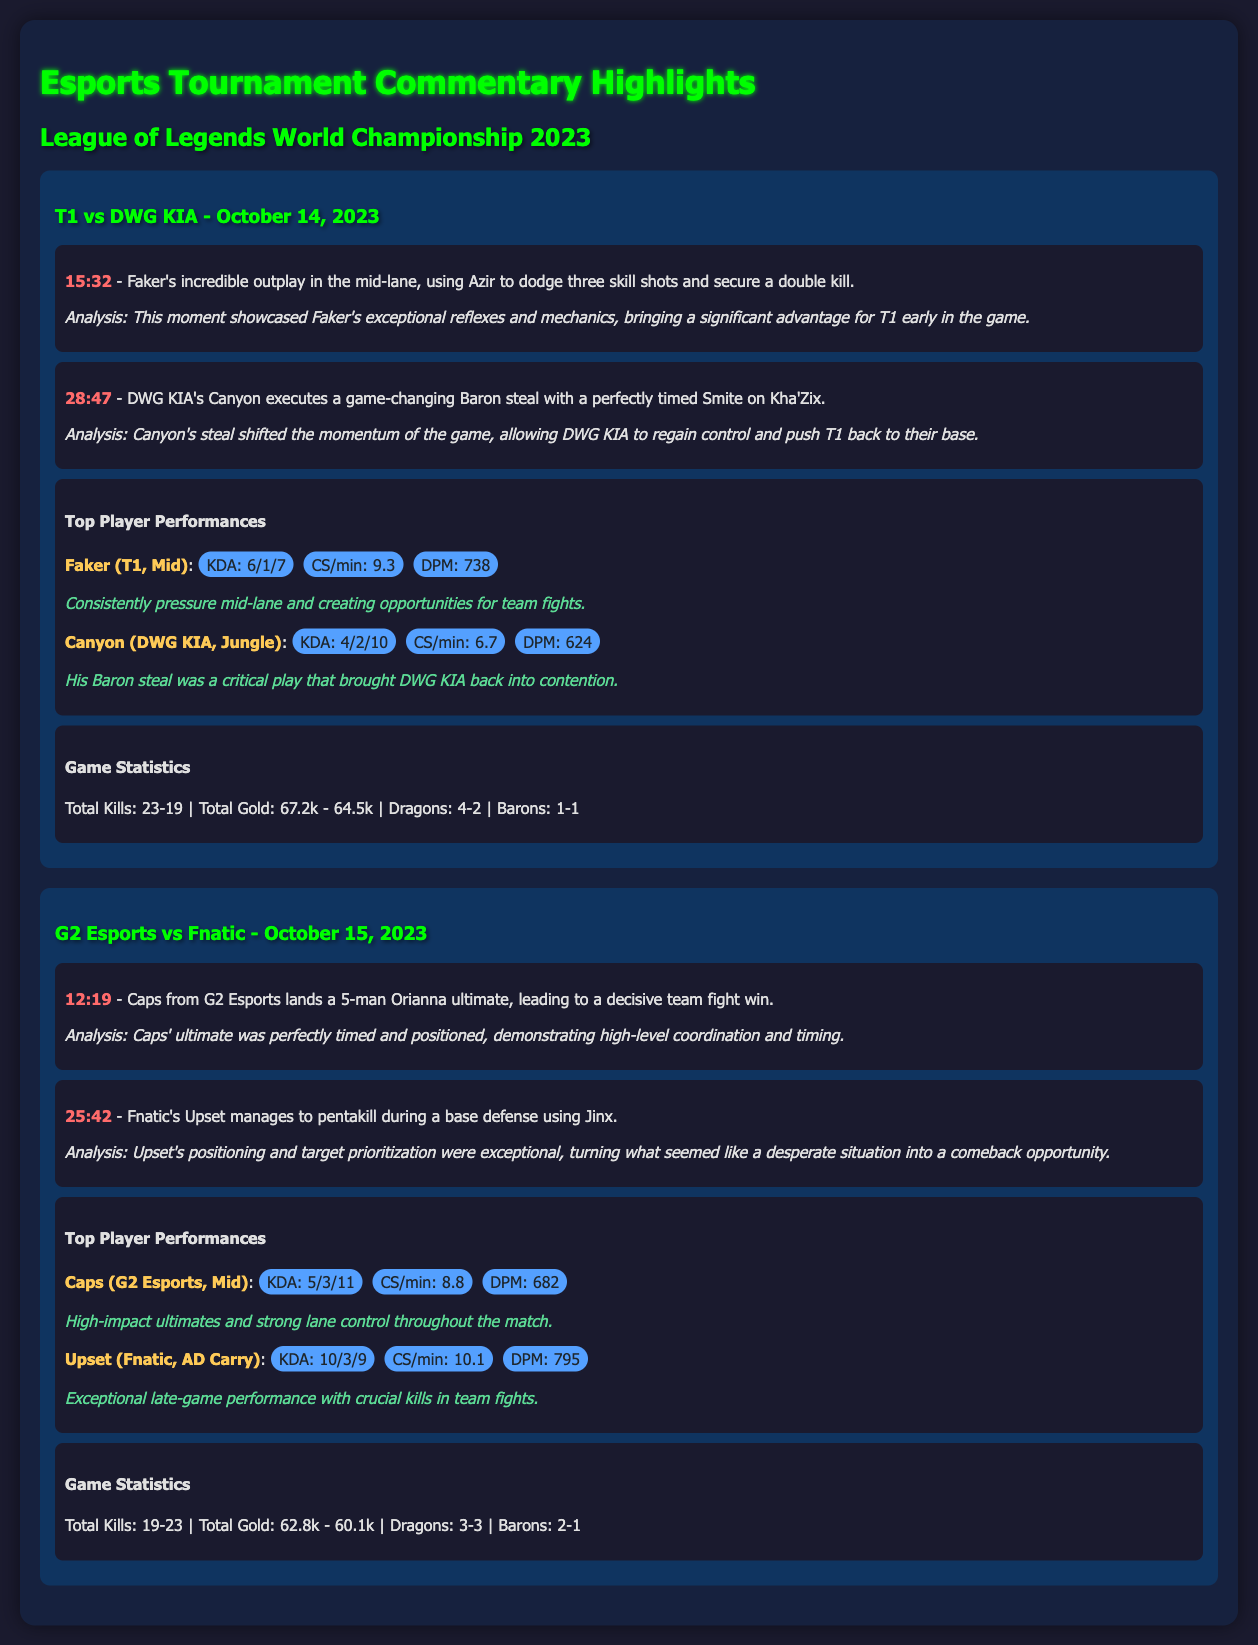What match occurred on October 14, 2023? The match on October 14, 2023, was between T1 and DWG KIA.
Answer: T1 vs DWG KIA Who secured a double kill at 15:32? At 15:32, Faker secured a double kill in the mid-lane.
Answer: Faker What was Canyon's KDA during the match? Canyon's KDA during the match was 4/2/10.
Answer: 4/2/10 How many dragons did T1 secure in the match against DWG KIA? T1 secured 4 dragons in the match against DWG KIA.
Answer: 4 What significant play did Caps make at 12:19? At 12:19, Caps landed a 5-man Orianna ultimate.
Answer: 5-man Orianna ultimate What was Upset's total kill count during the match? Upset's total kill count during the match was 10.
Answer: 10 How many total kills were there in the match between G2 Esports and Fnatic? The total kills in the match between G2 Esports and Fnatic were 42.
Answer: 42 Which player had the highest DPM in the T1 vs DWG KIA match? Faker had the highest DPM in the T1 vs DWG KIA match with 738.
Answer: 738 What color scheme is used for the document's background? The document's background features a dark color scheme, specifically shades of dark blue and gray.
Answer: Dark blue and gray 